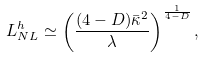Convert formula to latex. <formula><loc_0><loc_0><loc_500><loc_500>L ^ { h } _ { N L } \simeq \left ( \frac { ( 4 - D ) \bar { \kappa } ^ { 2 } } { \lambda } \right ) ^ { \frac { 1 } { 4 - D } } ,</formula> 